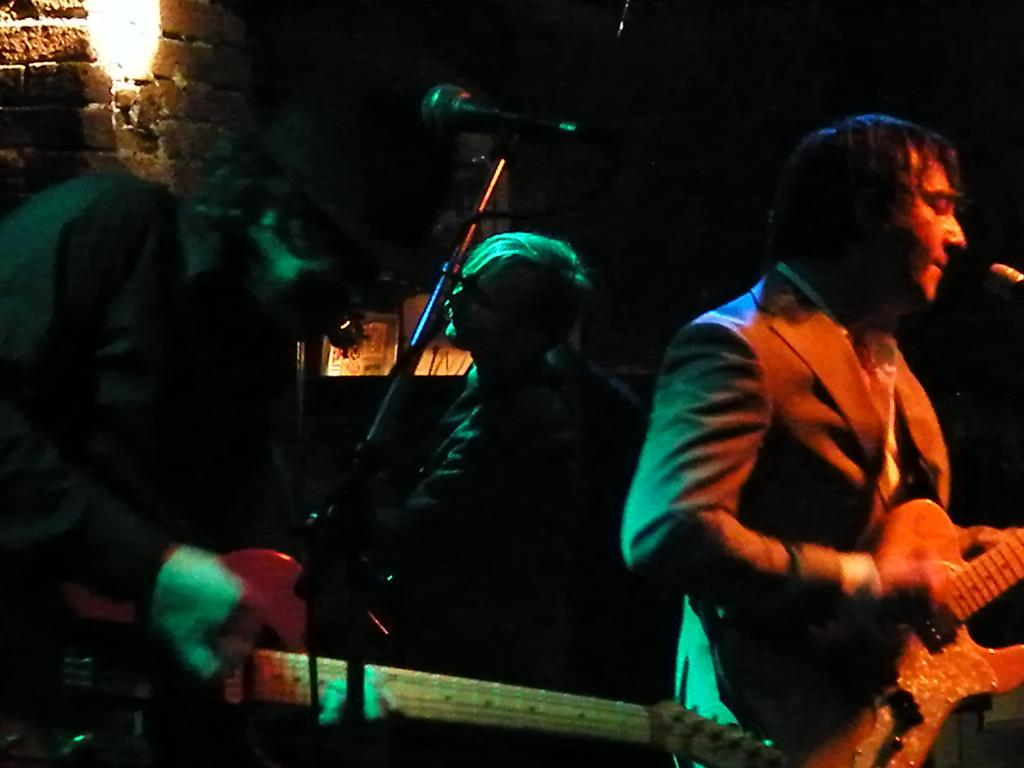How many people are in the image? There are three people in the image. What are the people doing in the image? The people are standing and playing musical instruments. What object is in front of the people? There is a microphone in front of the people. What can be seen in the background of the image? There is a brick wall and a light in the background of the image. What type of scarf is the drum wearing in the image? There is no drum or scarf present in the image; the people are playing musical instruments, but none of them are drums. 